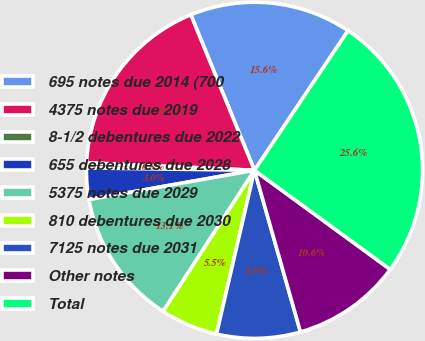Convert chart. <chart><loc_0><loc_0><loc_500><loc_500><pie_chart><fcel>695 notes due 2014 (700<fcel>4375 notes due 2019<fcel>8-1/2 debentures due 2022<fcel>655 debentures due 2028<fcel>5375 notes due 2029<fcel>810 debentures due 2030<fcel>7125 notes due 2031<fcel>Other notes<fcel>Total<nl><fcel>15.58%<fcel>18.1%<fcel>0.49%<fcel>3.01%<fcel>13.07%<fcel>5.52%<fcel>8.04%<fcel>10.55%<fcel>25.64%<nl></chart> 